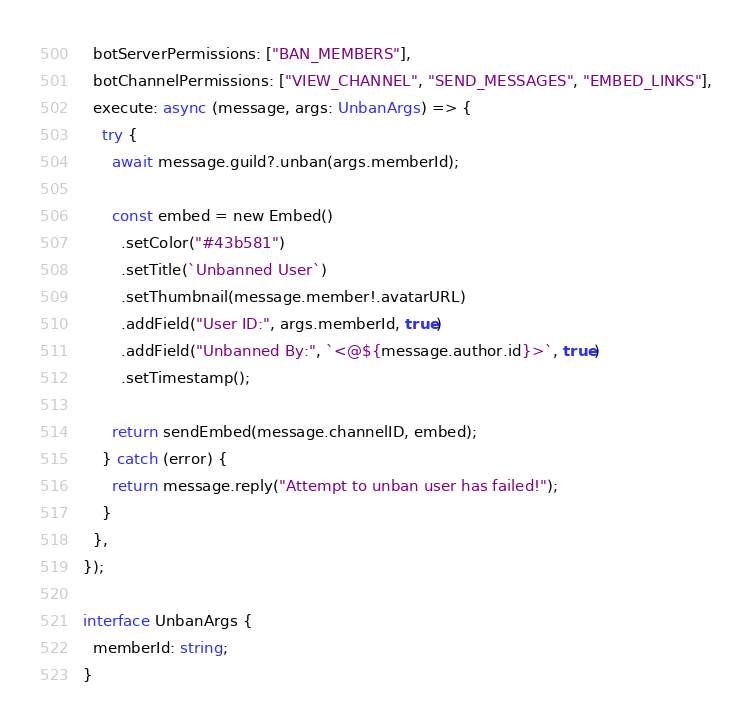<code> <loc_0><loc_0><loc_500><loc_500><_TypeScript_>  botServerPermissions: ["BAN_MEMBERS"],
  botChannelPermissions: ["VIEW_CHANNEL", "SEND_MESSAGES", "EMBED_LINKS"],
  execute: async (message, args: UnbanArgs) => {
    try {
      await message.guild?.unban(args.memberId);

      const embed = new Embed()
        .setColor("#43b581")
        .setTitle(`Unbanned User`)
        .setThumbnail(message.member!.avatarURL)
        .addField("User ID:", args.memberId, true)
        .addField("Unbanned By:", `<@${message.author.id}>`, true)
        .setTimestamp();

      return sendEmbed(message.channelID, embed);
    } catch (error) {
      return message.reply("Attempt to unban user has failed!");
    }
  },
});

interface UnbanArgs {
  memberId: string;
}
</code> 